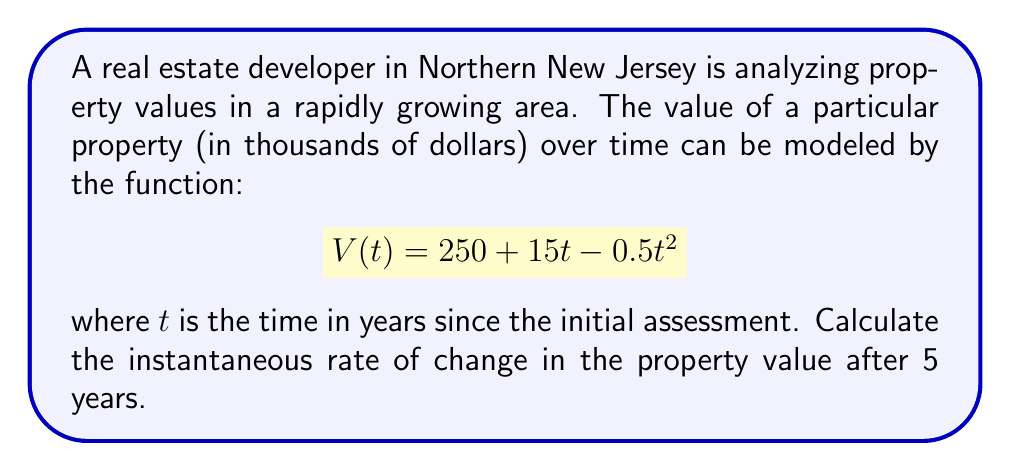Could you help me with this problem? To solve this problem, we need to find the derivative of the given function and then evaluate it at $t = 5$. This will give us the instantaneous rate of change in property value after 5 years.

1. First, let's find the derivative of $V(t)$:
   $$V(t) = 250 + 15t - 0.5t^2$$
   $$V'(t) = 15 - t$$

   The derivative represents the rate of change of the property value with respect to time.

2. Now, we need to evaluate $V'(t)$ at $t = 5$:
   $$V'(5) = 15 - 5 = 10$$

3. Interpreting the result:
   The value 10 represents the instantaneous rate of change in thousands of dollars per year. To convert this to dollars per year, we multiply by 1000:
   $$10 * 1000 = 10,000$$

Therefore, after 5 years, the property value is increasing at a rate of $10,000 per year.
Answer: The instantaneous rate of change in the property value after 5 years is $10,000 per year. 